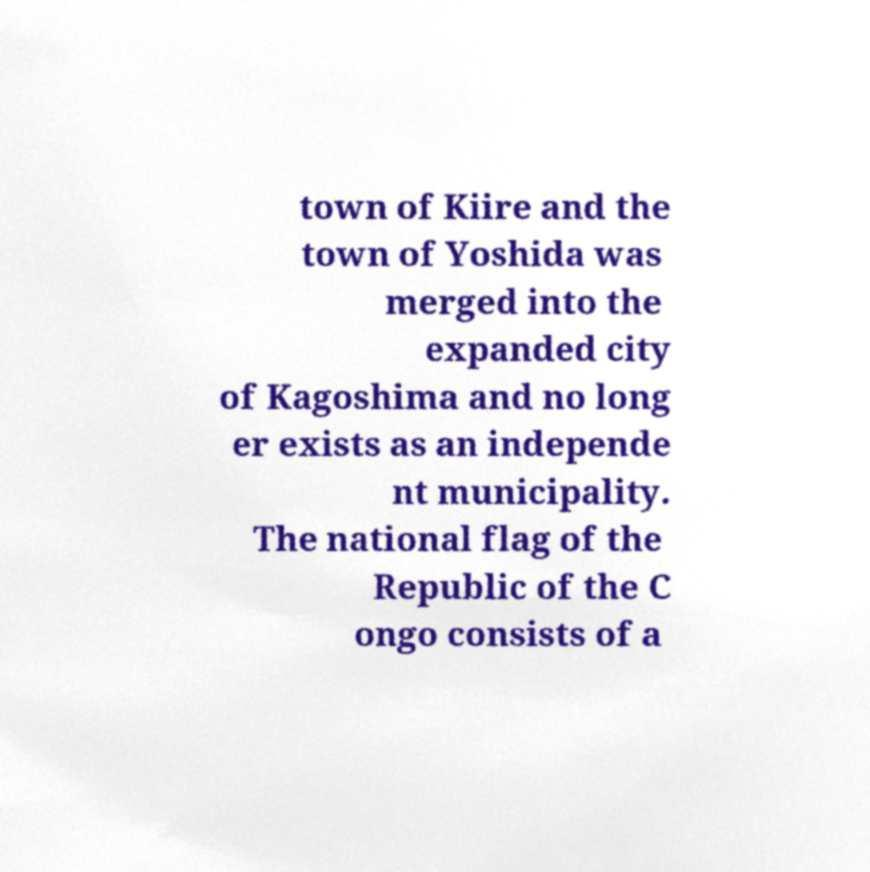I need the written content from this picture converted into text. Can you do that? town of Kiire and the town of Yoshida was merged into the expanded city of Kagoshima and no long er exists as an independe nt municipality. The national flag of the Republic of the C ongo consists of a 